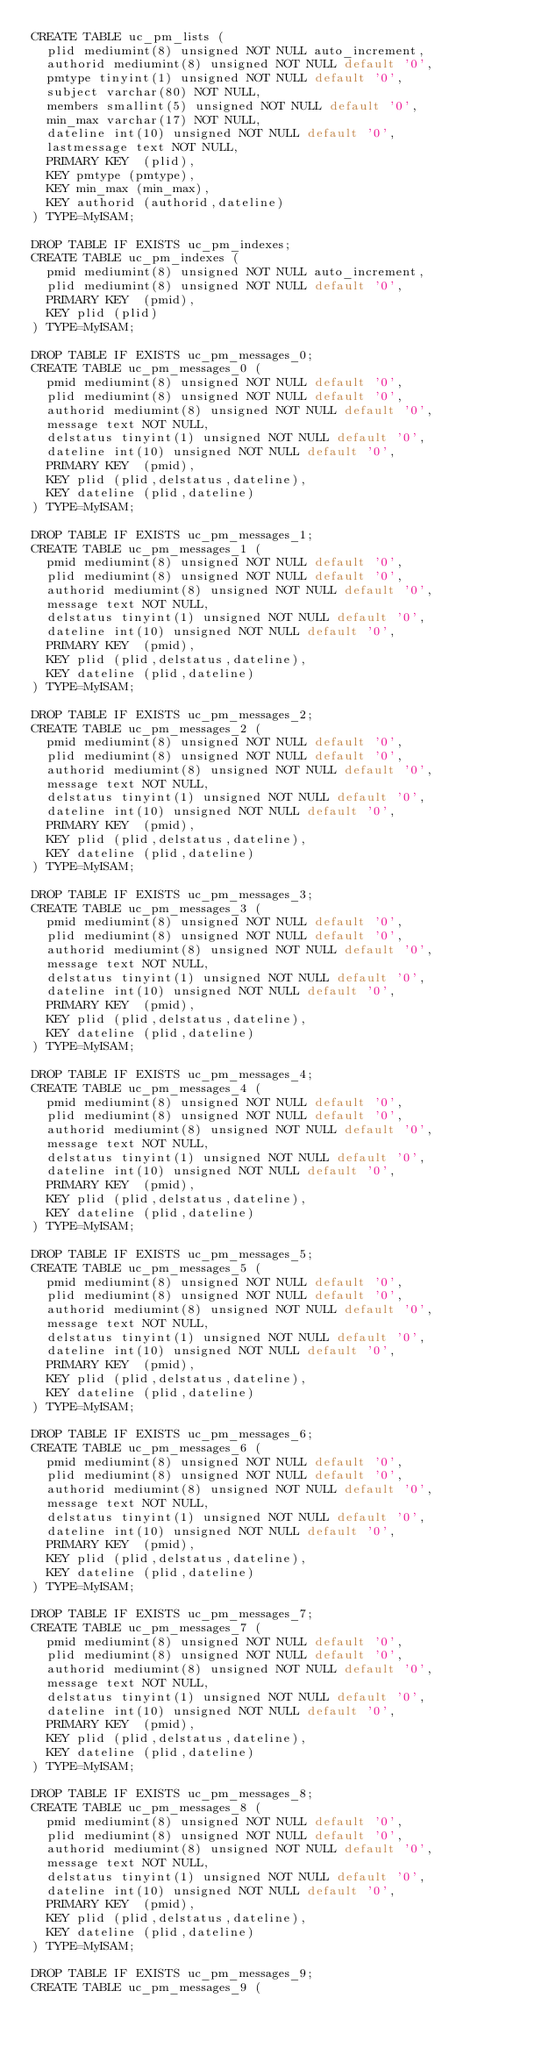<code> <loc_0><loc_0><loc_500><loc_500><_SQL_>CREATE TABLE uc_pm_lists (
  plid mediumint(8) unsigned NOT NULL auto_increment,
  authorid mediumint(8) unsigned NOT NULL default '0',
  pmtype tinyint(1) unsigned NOT NULL default '0',
  subject varchar(80) NOT NULL,
  members smallint(5) unsigned NOT NULL default '0',
  min_max varchar(17) NOT NULL,
  dateline int(10) unsigned NOT NULL default '0',
  lastmessage text NOT NULL,
  PRIMARY KEY  (plid),
  KEY pmtype (pmtype),
  KEY min_max (min_max),
  KEY authorid (authorid,dateline)
) TYPE=MyISAM;

DROP TABLE IF EXISTS uc_pm_indexes;
CREATE TABLE uc_pm_indexes (
  pmid mediumint(8) unsigned NOT NULL auto_increment,
  plid mediumint(8) unsigned NOT NULL default '0',
  PRIMARY KEY  (pmid),
  KEY plid (plid)
) TYPE=MyISAM;

DROP TABLE IF EXISTS uc_pm_messages_0;
CREATE TABLE uc_pm_messages_0 (
  pmid mediumint(8) unsigned NOT NULL default '0',
  plid mediumint(8) unsigned NOT NULL default '0',
  authorid mediumint(8) unsigned NOT NULL default '0',
  message text NOT NULL,
  delstatus tinyint(1) unsigned NOT NULL default '0',
  dateline int(10) unsigned NOT NULL default '0',
  PRIMARY KEY  (pmid),
  KEY plid (plid,delstatus,dateline),
  KEY dateline (plid,dateline)
) TYPE=MyISAM;

DROP TABLE IF EXISTS uc_pm_messages_1;
CREATE TABLE uc_pm_messages_1 (
  pmid mediumint(8) unsigned NOT NULL default '0',
  plid mediumint(8) unsigned NOT NULL default '0',
  authorid mediumint(8) unsigned NOT NULL default '0',
  message text NOT NULL,
  delstatus tinyint(1) unsigned NOT NULL default '0',
  dateline int(10) unsigned NOT NULL default '0',
  PRIMARY KEY  (pmid),
  KEY plid (plid,delstatus,dateline),
  KEY dateline (plid,dateline)
) TYPE=MyISAM;

DROP TABLE IF EXISTS uc_pm_messages_2;
CREATE TABLE uc_pm_messages_2 (
  pmid mediumint(8) unsigned NOT NULL default '0',
  plid mediumint(8) unsigned NOT NULL default '0',
  authorid mediumint(8) unsigned NOT NULL default '0',
  message text NOT NULL,
  delstatus tinyint(1) unsigned NOT NULL default '0',
  dateline int(10) unsigned NOT NULL default '0',
  PRIMARY KEY  (pmid),
  KEY plid (plid,delstatus,dateline),
  KEY dateline (plid,dateline)
) TYPE=MyISAM;

DROP TABLE IF EXISTS uc_pm_messages_3;
CREATE TABLE uc_pm_messages_3 (
  pmid mediumint(8) unsigned NOT NULL default '0',
  plid mediumint(8) unsigned NOT NULL default '0',
  authorid mediumint(8) unsigned NOT NULL default '0',
  message text NOT NULL,
  delstatus tinyint(1) unsigned NOT NULL default '0',
  dateline int(10) unsigned NOT NULL default '0',
  PRIMARY KEY  (pmid),
  KEY plid (plid,delstatus,dateline),
  KEY dateline (plid,dateline)
) TYPE=MyISAM;

DROP TABLE IF EXISTS uc_pm_messages_4;
CREATE TABLE uc_pm_messages_4 (
  pmid mediumint(8) unsigned NOT NULL default '0',
  plid mediumint(8) unsigned NOT NULL default '0',
  authorid mediumint(8) unsigned NOT NULL default '0',
  message text NOT NULL,
  delstatus tinyint(1) unsigned NOT NULL default '0',
  dateline int(10) unsigned NOT NULL default '0',
  PRIMARY KEY  (pmid),
  KEY plid (plid,delstatus,dateline),
  KEY dateline (plid,dateline)
) TYPE=MyISAM;

DROP TABLE IF EXISTS uc_pm_messages_5;
CREATE TABLE uc_pm_messages_5 (
  pmid mediumint(8) unsigned NOT NULL default '0',
  plid mediumint(8) unsigned NOT NULL default '0',
  authorid mediumint(8) unsigned NOT NULL default '0',
  message text NOT NULL,
  delstatus tinyint(1) unsigned NOT NULL default '0',
  dateline int(10) unsigned NOT NULL default '0',
  PRIMARY KEY  (pmid),
  KEY plid (plid,delstatus,dateline),
  KEY dateline (plid,dateline)
) TYPE=MyISAM;

DROP TABLE IF EXISTS uc_pm_messages_6;
CREATE TABLE uc_pm_messages_6 (
  pmid mediumint(8) unsigned NOT NULL default '0',
  plid mediumint(8) unsigned NOT NULL default '0',
  authorid mediumint(8) unsigned NOT NULL default '0',
  message text NOT NULL,
  delstatus tinyint(1) unsigned NOT NULL default '0',
  dateline int(10) unsigned NOT NULL default '0',
  PRIMARY KEY  (pmid),
  KEY plid (plid,delstatus,dateline),
  KEY dateline (plid,dateline)
) TYPE=MyISAM;

DROP TABLE IF EXISTS uc_pm_messages_7;
CREATE TABLE uc_pm_messages_7 (
  pmid mediumint(8) unsigned NOT NULL default '0',
  plid mediumint(8) unsigned NOT NULL default '0',
  authorid mediumint(8) unsigned NOT NULL default '0',
  message text NOT NULL,
  delstatus tinyint(1) unsigned NOT NULL default '0',
  dateline int(10) unsigned NOT NULL default '0',
  PRIMARY KEY  (pmid),
  KEY plid (plid,delstatus,dateline),
  KEY dateline (plid,dateline)
) TYPE=MyISAM;

DROP TABLE IF EXISTS uc_pm_messages_8;
CREATE TABLE uc_pm_messages_8 (
  pmid mediumint(8) unsigned NOT NULL default '0',
  plid mediumint(8) unsigned NOT NULL default '0',
  authorid mediumint(8) unsigned NOT NULL default '0',
  message text NOT NULL,
  delstatus tinyint(1) unsigned NOT NULL default '0',
  dateline int(10) unsigned NOT NULL default '0',
  PRIMARY KEY  (pmid),
  KEY plid (plid,delstatus,dateline),
  KEY dateline (plid,dateline)
) TYPE=MyISAM;

DROP TABLE IF EXISTS uc_pm_messages_9;
CREATE TABLE uc_pm_messages_9 (</code> 